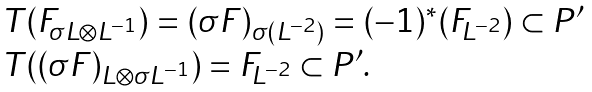<formula> <loc_0><loc_0><loc_500><loc_500>\begin{array} { l } T ( F _ { \sigma L \otimes L ^ { - 1 } } ) = ( \sigma F ) _ { \sigma ( L ^ { - 2 } ) } = ( - 1 ) ^ { \ast } ( F _ { L ^ { - 2 } } ) \subset P ^ { \prime } \\ T ( ( \sigma F ) _ { L \otimes \sigma L ^ { - 1 } } ) = F _ { L ^ { - 2 } } \subset P ^ { \prime } . \end{array}</formula> 